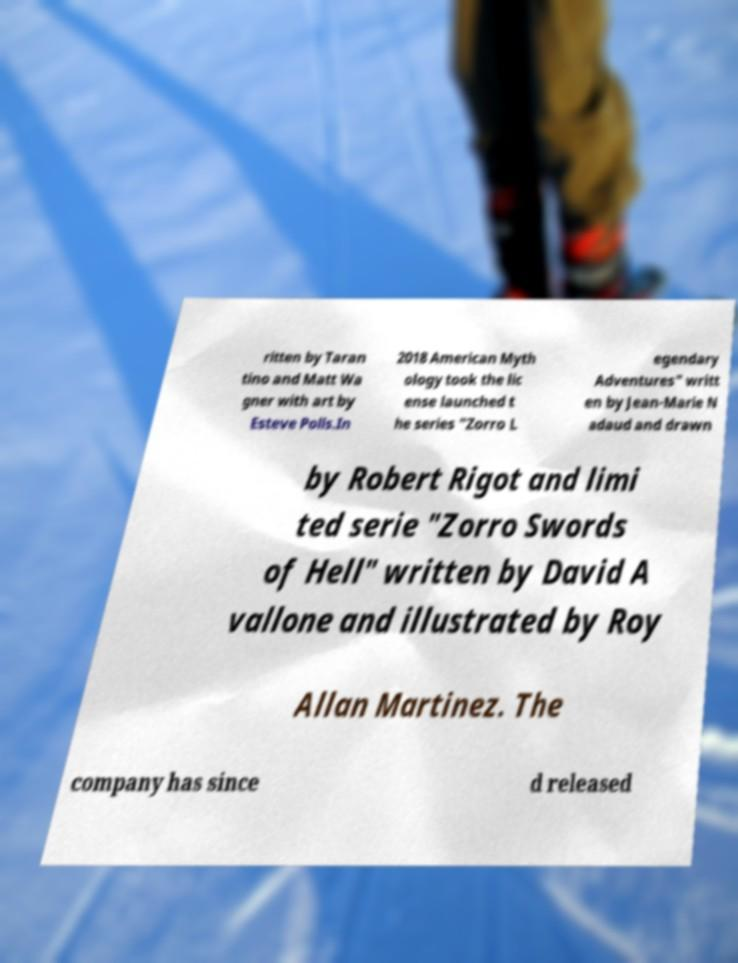I need the written content from this picture converted into text. Can you do that? ritten by Taran tino and Matt Wa gner with art by Esteve Polls.In 2018 American Myth ology took the lic ense launched t he series "Zorro L egendary Adventures" writt en by Jean-Marie N adaud and drawn by Robert Rigot and limi ted serie "Zorro Swords of Hell" written by David A vallone and illustrated by Roy Allan Martinez. The company has since d released 